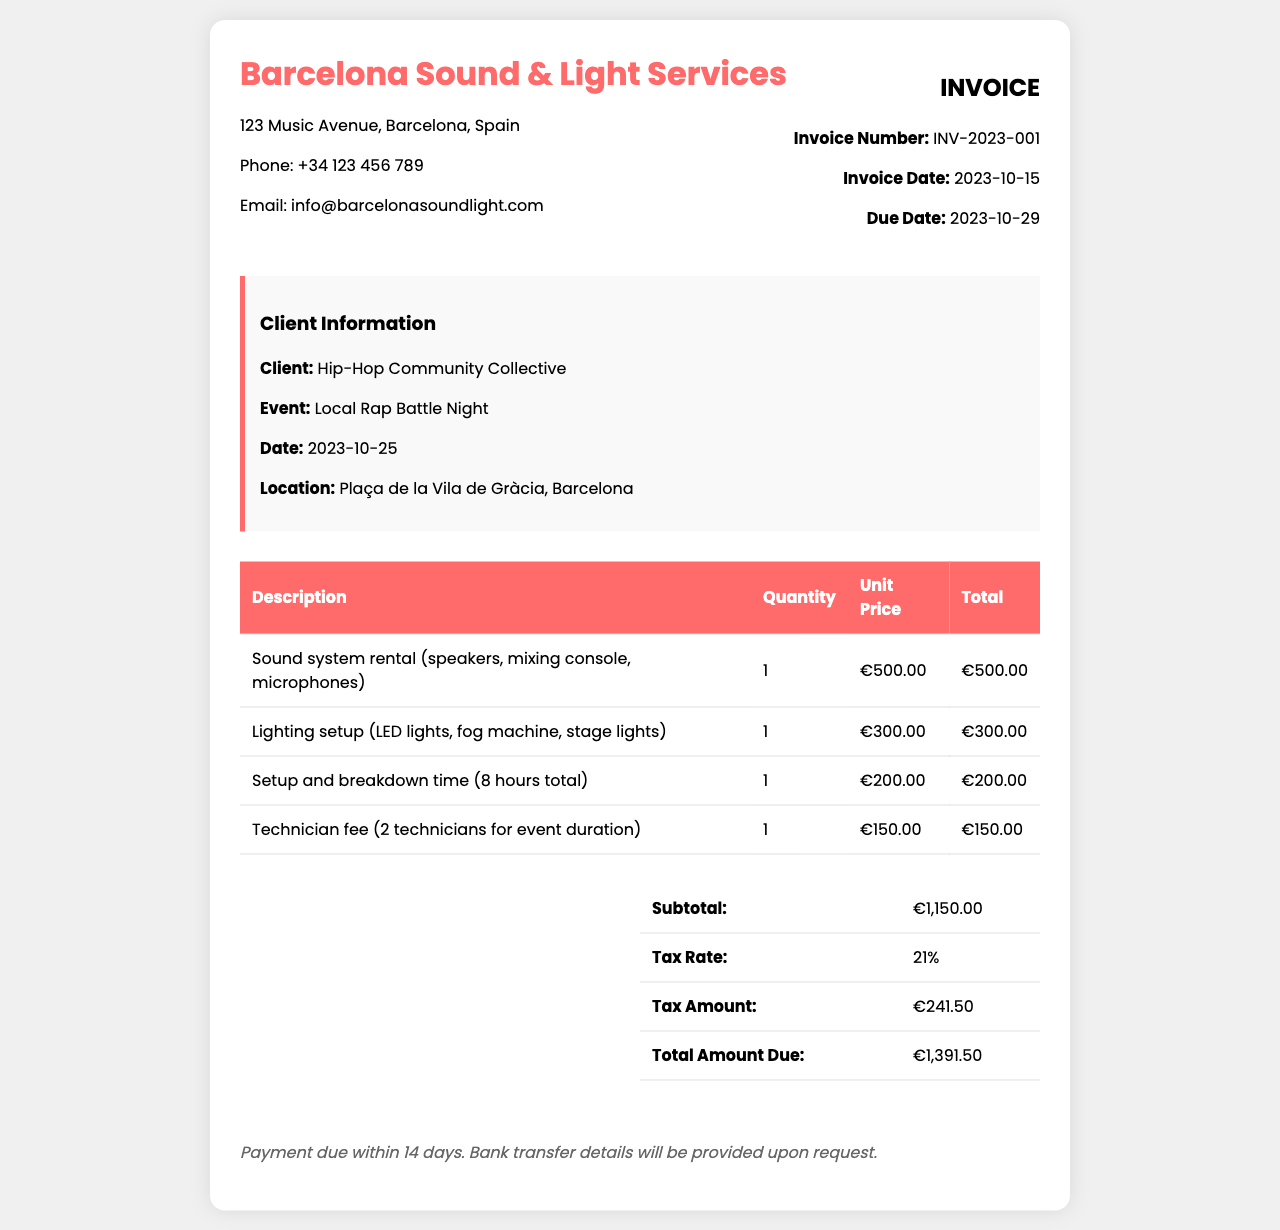What is the invoice number? The invoice number is a unique identifier for this document, listed under invoice details.
Answer: INV-2023-001 What is the total amount due? The total amount due is calculated at the bottom of the invoice, summarizing all costs, including tax.
Answer: €1,391.50 What is the client name? The client name is specified in the client information section of the document.
Answer: Hip-Hop Community Collective When is the event date? The event date can be found in the client information section.
Answer: 2023-10-25 What is the tax rate applied? The tax rate is mentioned in the summary section of the invoice.
Answer: 21% How much is the technician fee? The technician fee is detailed in the line items of the invoice, specifically for two technicians.
Answer: €150.00 What items are included in the sound system rental? The sound system rental includes various equipment listed in the description column of the invoice.
Answer: speakers, mixing console, microphones What is the setup and breakdown time cost? The cost for the setup and breakdown time is clearly mentioned in the line items.
Answer: €200.00 Where is the event location? The event location can be found in the client information section of the document.
Answer: Plaça de la Vila de Gràcia, Barcelona 